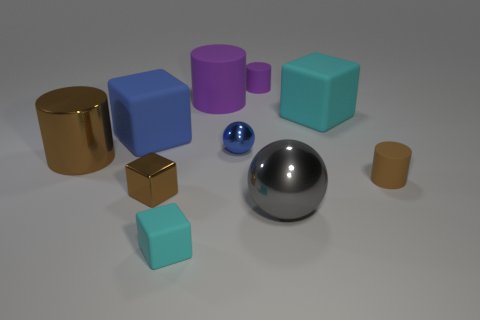There is a blue thing that is made of the same material as the gray sphere; what is its shape?
Provide a short and direct response. Sphere. Is the big cyan rubber object the same shape as the small purple matte thing?
Keep it short and to the point. No. The big metallic cylinder has what color?
Offer a very short reply. Brown. How many things are either big cyan shiny objects or big brown things?
Offer a very short reply. 1. Is there anything else that is the same material as the large gray ball?
Offer a very short reply. Yes. Is the number of small brown cylinders to the left of the small blue metal sphere less than the number of tiny shiny spheres?
Offer a very short reply. Yes. Are there more large metal cylinders in front of the metallic cylinder than tiny shiny cubes that are in front of the large ball?
Your answer should be compact. No. Are there any other things of the same color as the large metal cylinder?
Provide a succinct answer. Yes. What is the material of the large block that is right of the small purple rubber cylinder?
Ensure brevity in your answer.  Rubber. Does the gray metal object have the same size as the metal cube?
Make the answer very short. No. 